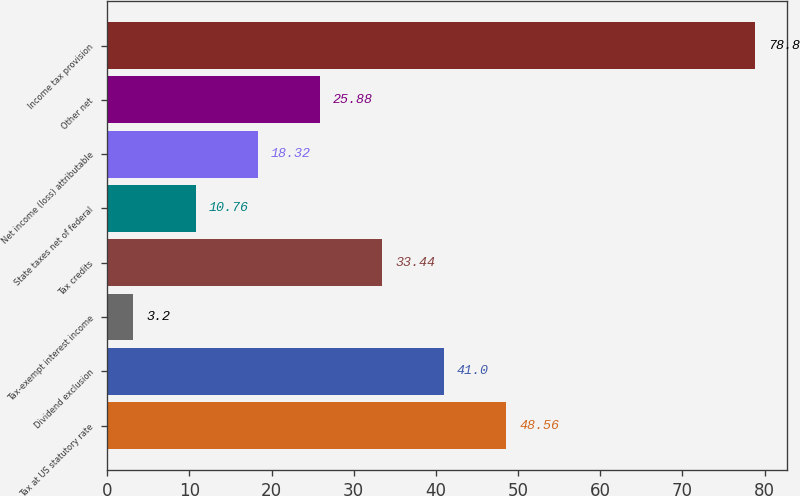Convert chart to OTSL. <chart><loc_0><loc_0><loc_500><loc_500><bar_chart><fcel>Tax at US statutory rate<fcel>Dividend exclusion<fcel>Tax-exempt interest income<fcel>Tax credits<fcel>State taxes net of federal<fcel>Net income (loss) attributable<fcel>Other net<fcel>Income tax provision<nl><fcel>48.56<fcel>41<fcel>3.2<fcel>33.44<fcel>10.76<fcel>18.32<fcel>25.88<fcel>78.8<nl></chart> 